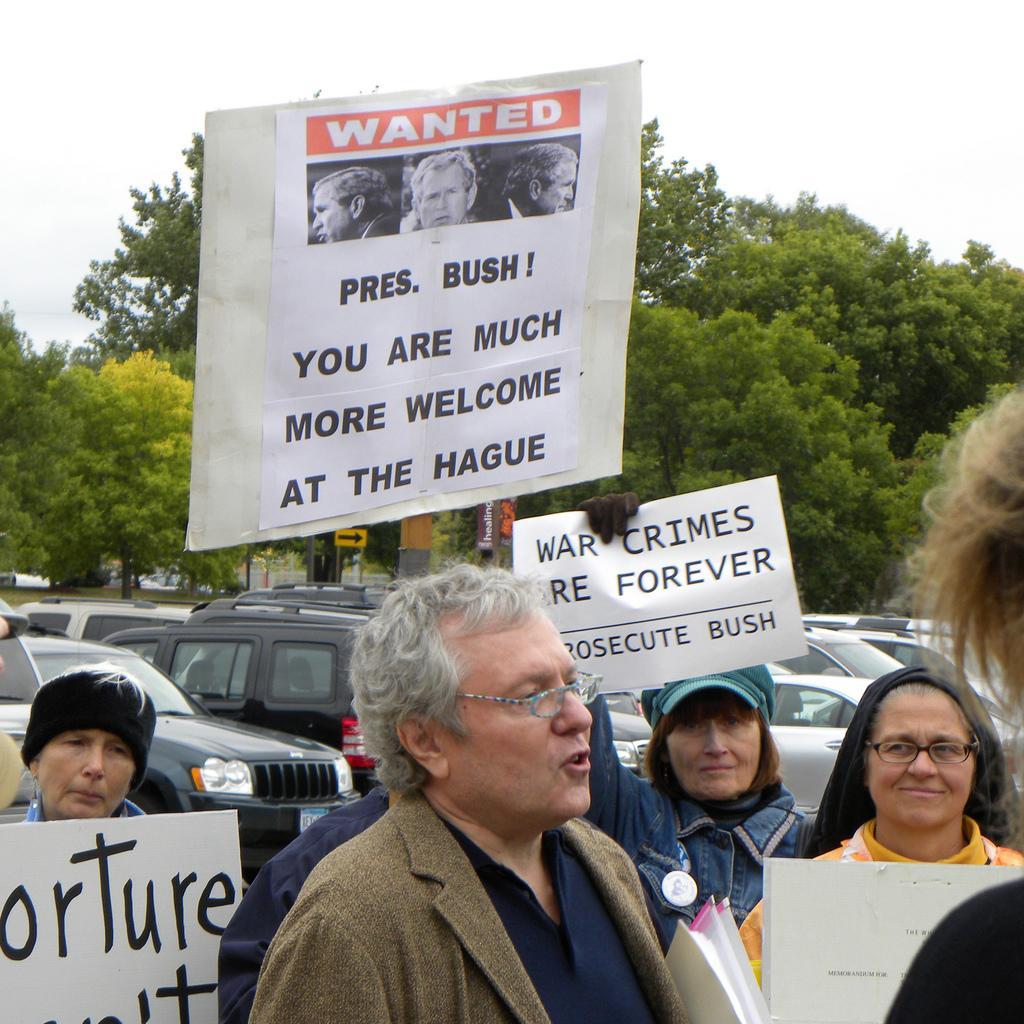Describe this image in one or two sentences. On the bottom there is a man who is wearing spectacle, blazer and shirt. Beside him we can see women was standing near to him and everyone is holding the posters. In the background we can see many cars which are parked near to the trees. Here we can see sign board near to the building. On the top there is a sky. 